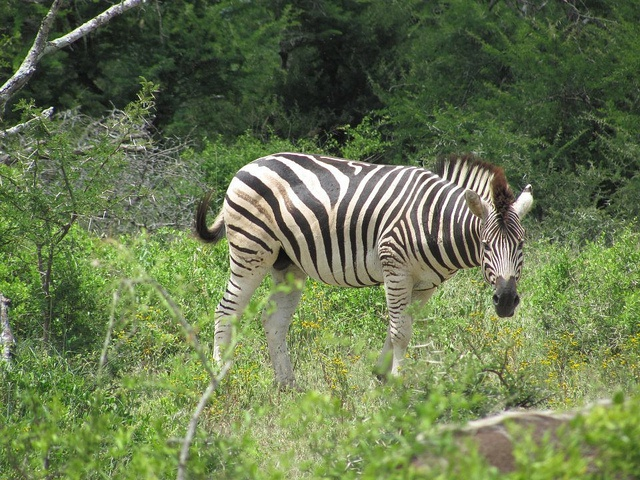Describe the objects in this image and their specific colors. I can see a zebra in darkgreen, gray, darkgray, and ivory tones in this image. 